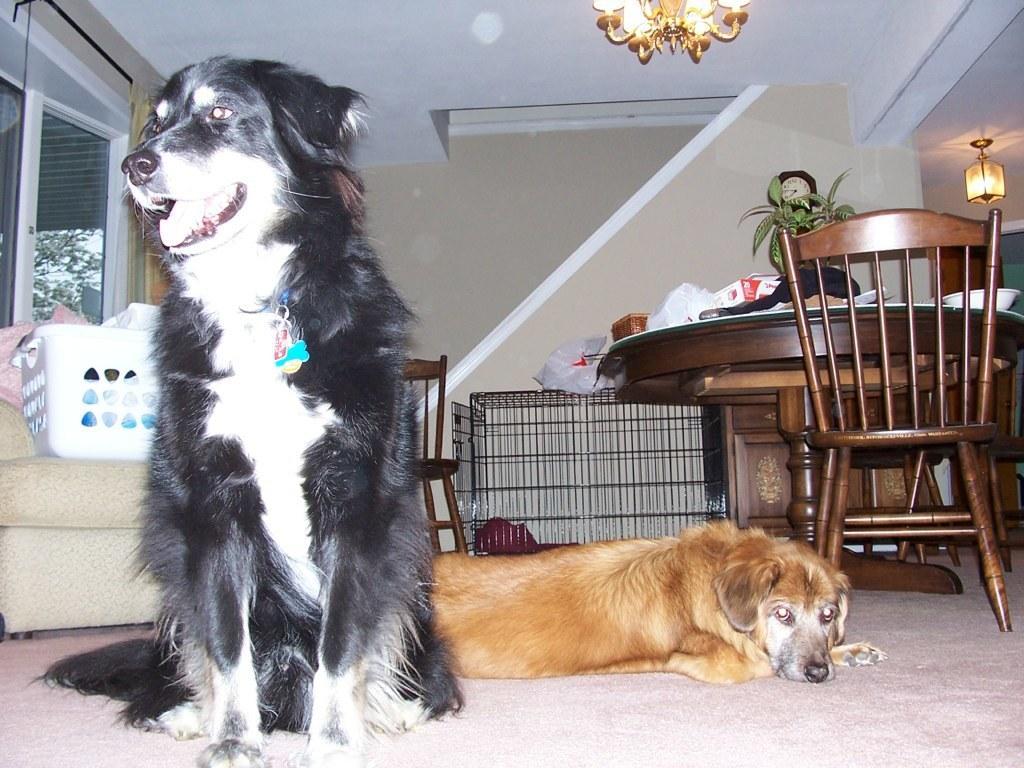Can you describe this image briefly? There are two dogs on the floor. This is carpet. There is a chair and this is table. Here we can see a sofa and this is door. On the background there is a wall and these are the lights. 